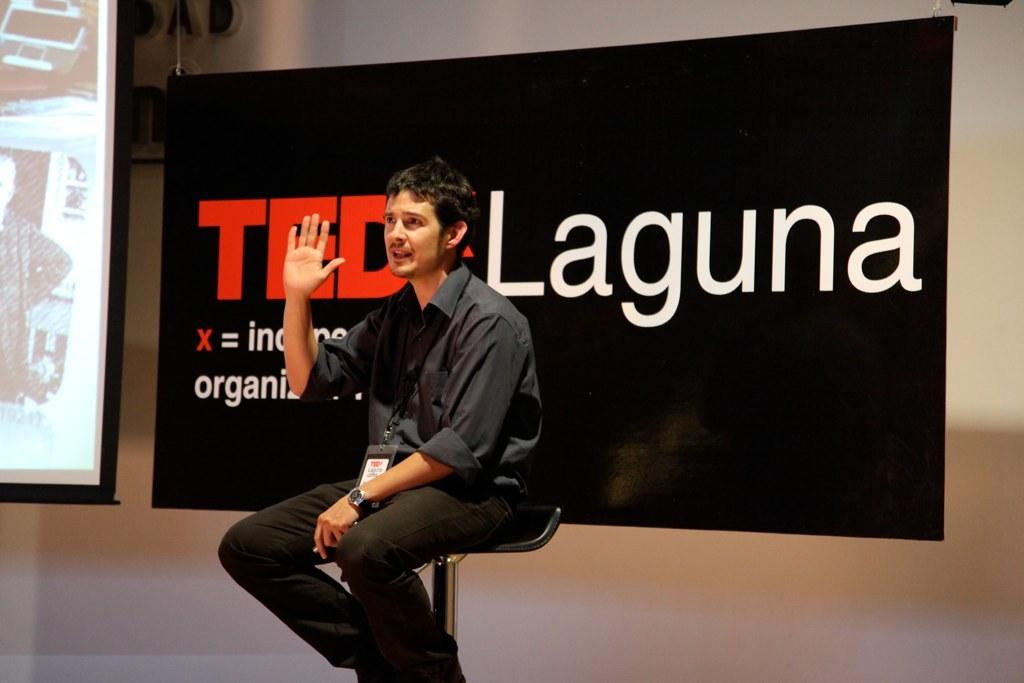What is the main subject of the image? There is a man in the image. Can you describe what the man is wearing? The man is wearing a shirt and trousers. He is also wearing a watch. What is the man doing in the image? The man is sitting on a chair. What can be seen in the background of the image? There is a banner visible in the background. What is on the left side of the image? There is a projector screen on the left side of the image. Is the man sinking in quicksand in the image? No, there is no quicksand present in the image. The man is sitting on a chair. What type of grass is growing on the projector screen? There is no grass visible in the image, as it features a man sitting on a chair, a banner in the background, and a projector screen on the left side. 